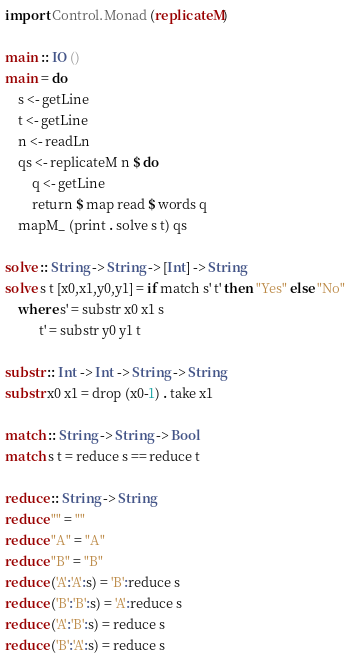Convert code to text. <code><loc_0><loc_0><loc_500><loc_500><_Haskell_>import Control.Monad (replicateM)

main :: IO ()
main = do
    s <- getLine
    t <- getLine
    n <- readLn
    qs <- replicateM n $ do
        q <- getLine
        return $ map read $ words q
    mapM_ (print . solve s t) qs

solve :: String -> String -> [Int] -> String
solve s t [x0,x1,y0,y1] = if match s' t' then "Yes" else "No"
    where s' = substr x0 x1 s
          t' = substr y0 y1 t

substr :: Int -> Int -> String -> String
substr x0 x1 = drop (x0-1) . take x1

match :: String -> String -> Bool
match s t = reduce s == reduce t

reduce :: String -> String
reduce "" = ""
reduce "A" = "A"
reduce "B" = "B"
reduce ('A':'A':s) = 'B':reduce s
reduce ('B':'B':s) = 'A':reduce s
reduce ('A':'B':s) = reduce s
reduce ('B':'A':s) = reduce s
</code> 